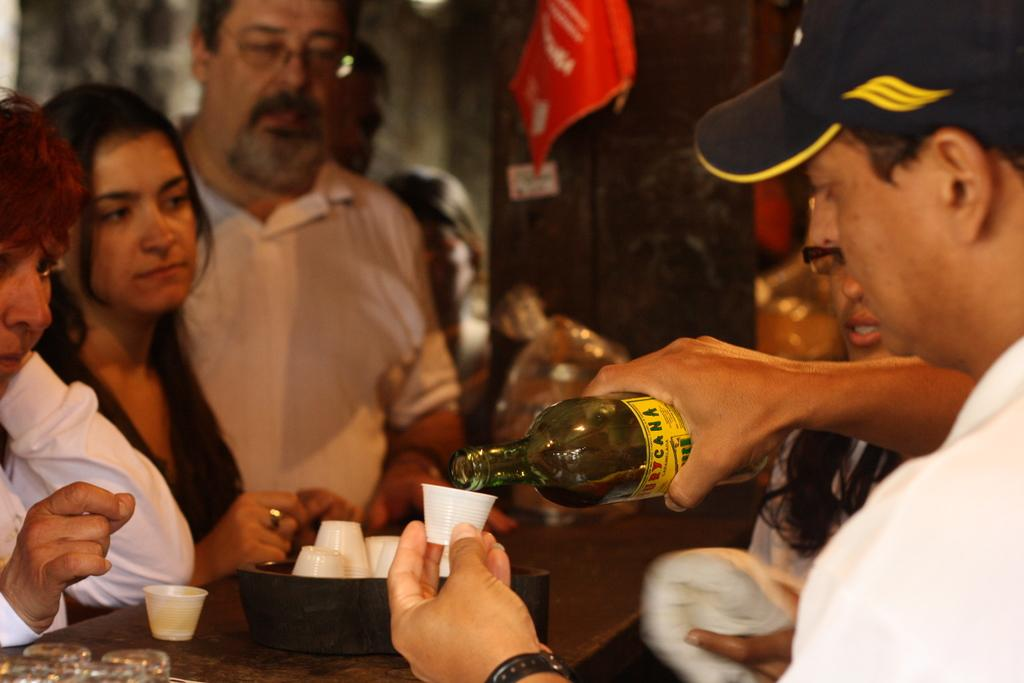How many people are in the image? There are persons in the image. What is one person doing with a bottle? One person is holding a bottle and pouring drink into a glass. What is the location of the action taking place? The action is taking place on or near a table, as mentioned in the image. What month is it in the image? The month is not mentioned or depicted in the image, so it cannot be determined. Can you tell me how many firemen are present in the image? There is no mention of firemen or any related activity in the image. 